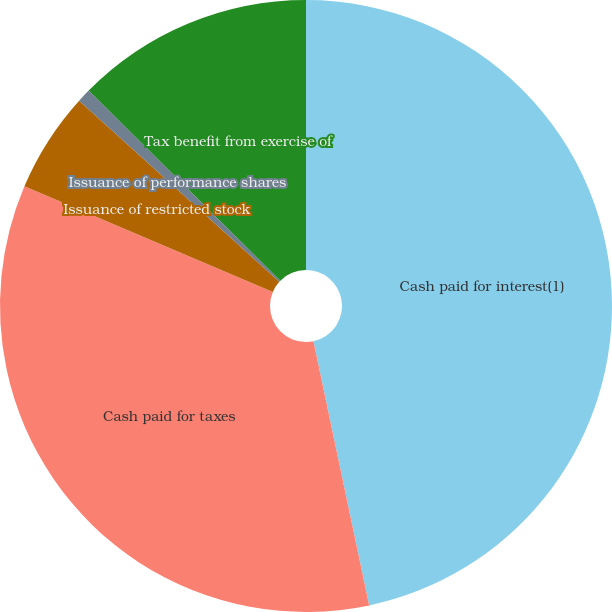Convert chart. <chart><loc_0><loc_0><loc_500><loc_500><pie_chart><fcel>Cash paid for interest(1)<fcel>Cash paid for taxes<fcel>Issuance of restricted stock<fcel>Issuance of performance shares<fcel>Tax benefit from exercise of<nl><fcel>46.69%<fcel>34.71%<fcel>5.31%<fcel>0.72%<fcel>12.57%<nl></chart> 